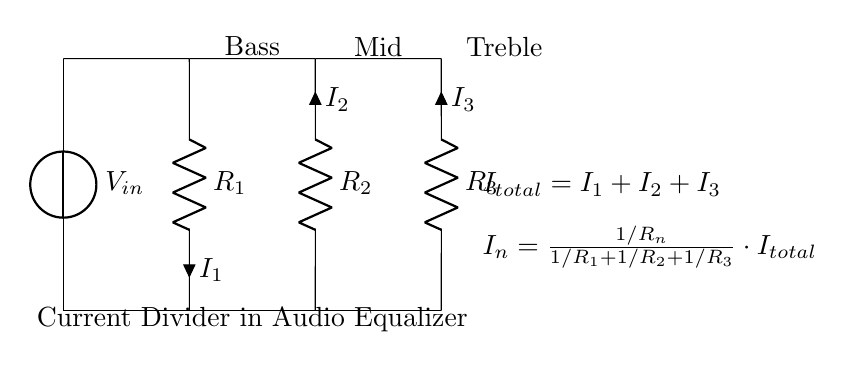What is the input voltage in the circuit? The input voltage is labeled as V_in, which is the voltage source at the top of the circuit diagram.
Answer: V_in What type of circuit is represented here? The circuit is a current divider circuit, indicated by the arrangement of resistors in parallel and labeled as such in the diagram.
Answer: Current divider circuit How many resistors are present in the circuit? There are three resistors labeled R_1, R_2, and R_3, shown in the circuit along with their corresponding connections.
Answer: 3 What is the formula for the current through resistor R_n? The formula provided in the circuit is I_n = (1/R_n) / (1/R_1 + 1/R_2 + 1/R_3) * I_total, which calculates the current divided among the resistors.
Answer: I_n = (1/R_n) / (1/R_1 + 1/R_2 + 1/R_3) * I_total What do the letters I_1, I_2, and I_3 represent? The letters I_1, I_2, and I_3 represent the individual currents flowing through resistors R_1, R_2, and R_3 respectively, as indicated next to each resistor in the diagram.
Answer: I_1, I_2, I_3 What is the total current in the circuit? The total current is represented by the equation I_total = I_1 + I_2 + I_3, which sums the currents flowing through all three resistors.
Answer: I_total Which part of the circuit is associated with 'Bass'? The part labeled as 'Bass' corresponds to R_1 in the circuit, indicating that this resistor is dedicated to the low-frequency sounds in the audio equalizer.
Answer: R_1 